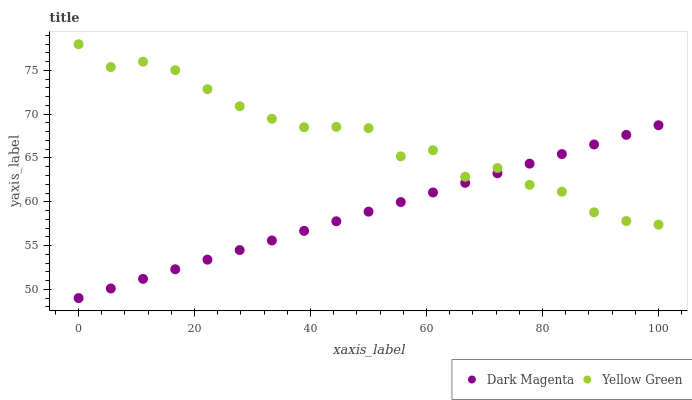Does Dark Magenta have the minimum area under the curve?
Answer yes or no. Yes. Does Yellow Green have the maximum area under the curve?
Answer yes or no. Yes. Does Yellow Green have the minimum area under the curve?
Answer yes or no. No. Is Dark Magenta the smoothest?
Answer yes or no. Yes. Is Yellow Green the roughest?
Answer yes or no. Yes. Is Yellow Green the smoothest?
Answer yes or no. No. Does Dark Magenta have the lowest value?
Answer yes or no. Yes. Does Yellow Green have the lowest value?
Answer yes or no. No. Does Yellow Green have the highest value?
Answer yes or no. Yes. Does Dark Magenta intersect Yellow Green?
Answer yes or no. Yes. Is Dark Magenta less than Yellow Green?
Answer yes or no. No. Is Dark Magenta greater than Yellow Green?
Answer yes or no. No. 